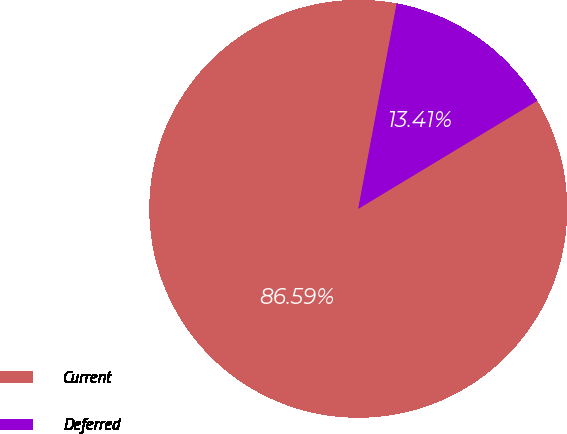Convert chart. <chart><loc_0><loc_0><loc_500><loc_500><pie_chart><fcel>Current<fcel>Deferred<nl><fcel>86.59%<fcel>13.41%<nl></chart> 